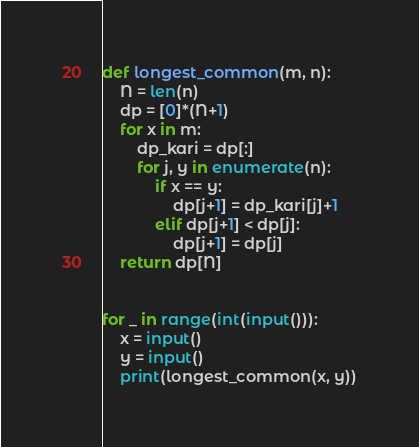<code> <loc_0><loc_0><loc_500><loc_500><_Python_>def longest_common(m, n):
	N = len(n)
	dp = [0]*(N+1)
	for x in m:
		dp_kari = dp[:]
		for j, y in enumerate(n):
			if x == y:
				dp[j+1] = dp_kari[j]+1
			elif dp[j+1] < dp[j]:
				dp[j+1] = dp[j]
	return dp[N]


for _ in range(int(input())):
    x = input()
    y = input()
    print(longest_common(x, y))

</code> 